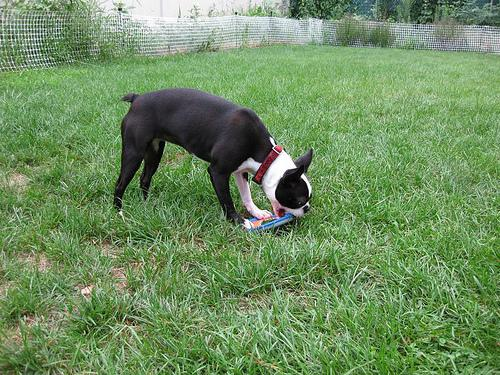Question: how many dogs are in the picture?
Choices:
A. 1.
B. 2.
C. 3.
D. 4.
Answer with the letter. Answer: A Question: where is this picture taken?
Choices:
A. Open field.
B. Mountains.
C. In a fenced in yard.
D. Orbit.
Answer with the letter. Answer: C Question: what is the weather like?
Choices:
A. Cloudy.
B. Raining.
C. Sunny.
D. Overcast.
Answer with the letter. Answer: C 